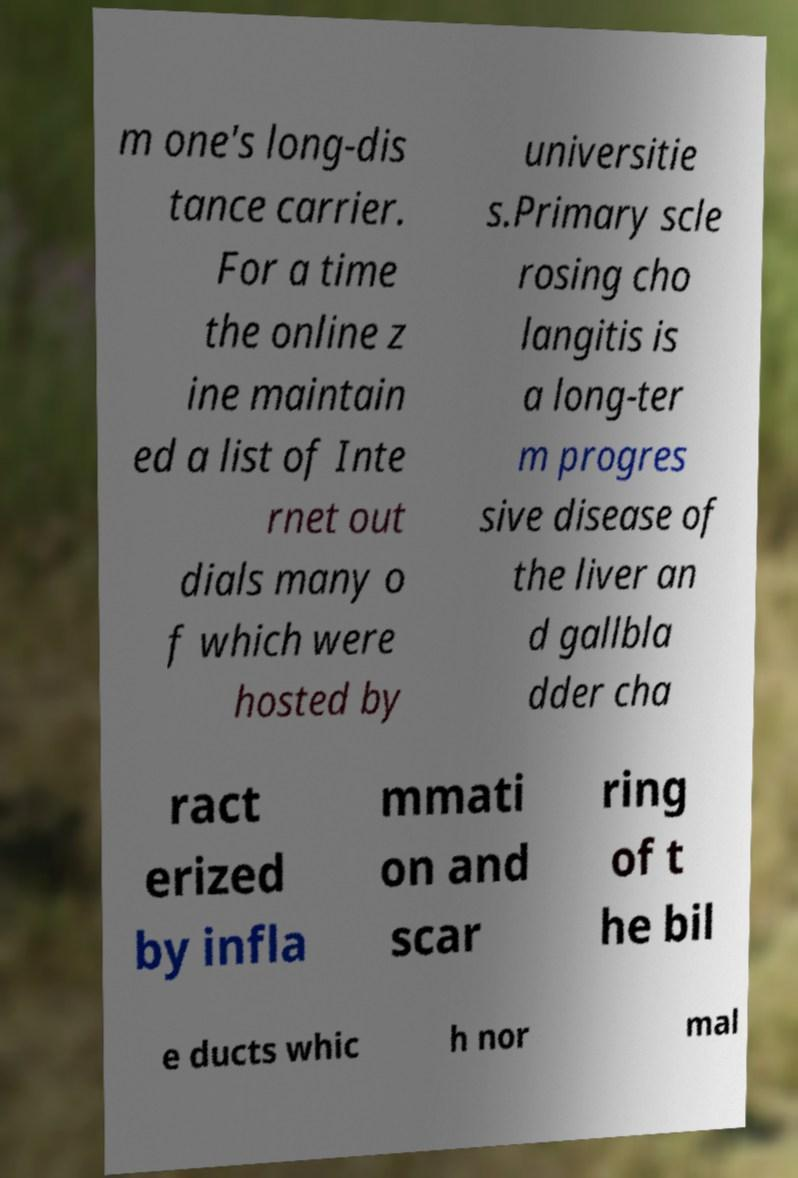There's text embedded in this image that I need extracted. Can you transcribe it verbatim? m one's long-dis tance carrier. For a time the online z ine maintain ed a list of Inte rnet out dials many o f which were hosted by universitie s.Primary scle rosing cho langitis is a long-ter m progres sive disease of the liver an d gallbla dder cha ract erized by infla mmati on and scar ring of t he bil e ducts whic h nor mal 